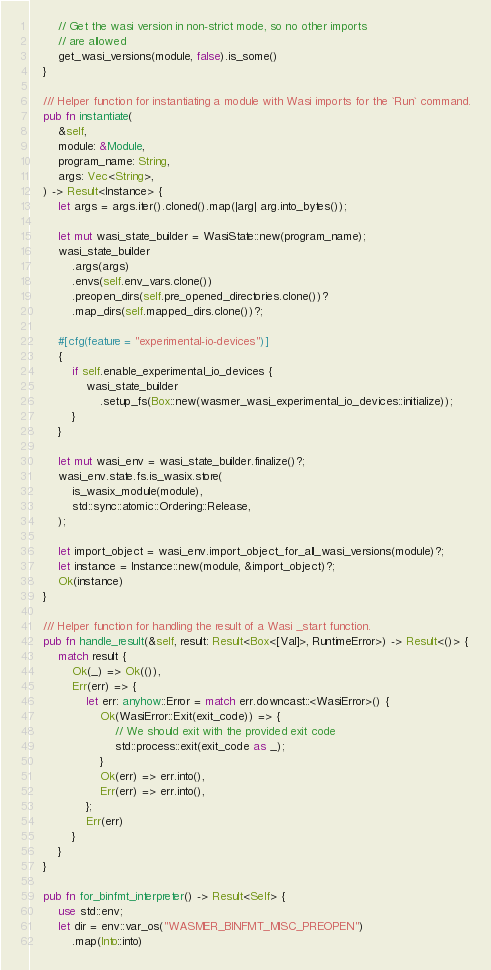<code> <loc_0><loc_0><loc_500><loc_500><_Rust_>        // Get the wasi version in non-strict mode, so no other imports
        // are allowed
        get_wasi_versions(module, false).is_some()
    }

    /// Helper function for instantiating a module with Wasi imports for the `Run` command.
    pub fn instantiate(
        &self,
        module: &Module,
        program_name: String,
        args: Vec<String>,
    ) -> Result<Instance> {
        let args = args.iter().cloned().map(|arg| arg.into_bytes());

        let mut wasi_state_builder = WasiState::new(program_name);
        wasi_state_builder
            .args(args)
            .envs(self.env_vars.clone())
            .preopen_dirs(self.pre_opened_directories.clone())?
            .map_dirs(self.mapped_dirs.clone())?;

        #[cfg(feature = "experimental-io-devices")]
        {
            if self.enable_experimental_io_devices {
                wasi_state_builder
                    .setup_fs(Box::new(wasmer_wasi_experimental_io_devices::initialize));
            }
        }

        let mut wasi_env = wasi_state_builder.finalize()?;
        wasi_env.state.fs.is_wasix.store(
            is_wasix_module(module),
            std::sync::atomic::Ordering::Release,
        );

        let import_object = wasi_env.import_object_for_all_wasi_versions(module)?;
        let instance = Instance::new(module, &import_object)?;
        Ok(instance)
    }

    /// Helper function for handling the result of a Wasi _start function.
    pub fn handle_result(&self, result: Result<Box<[Val]>, RuntimeError>) -> Result<()> {
        match result {
            Ok(_) => Ok(()),
            Err(err) => {
                let err: anyhow::Error = match err.downcast::<WasiError>() {
                    Ok(WasiError::Exit(exit_code)) => {
                        // We should exit with the provided exit code
                        std::process::exit(exit_code as _);
                    }
                    Ok(err) => err.into(),
                    Err(err) => err.into(),
                };
                Err(err)
            }
        }
    }

    pub fn for_binfmt_interpreter() -> Result<Self> {
        use std::env;
        let dir = env::var_os("WASMER_BINFMT_MISC_PREOPEN")
            .map(Into::into)</code> 